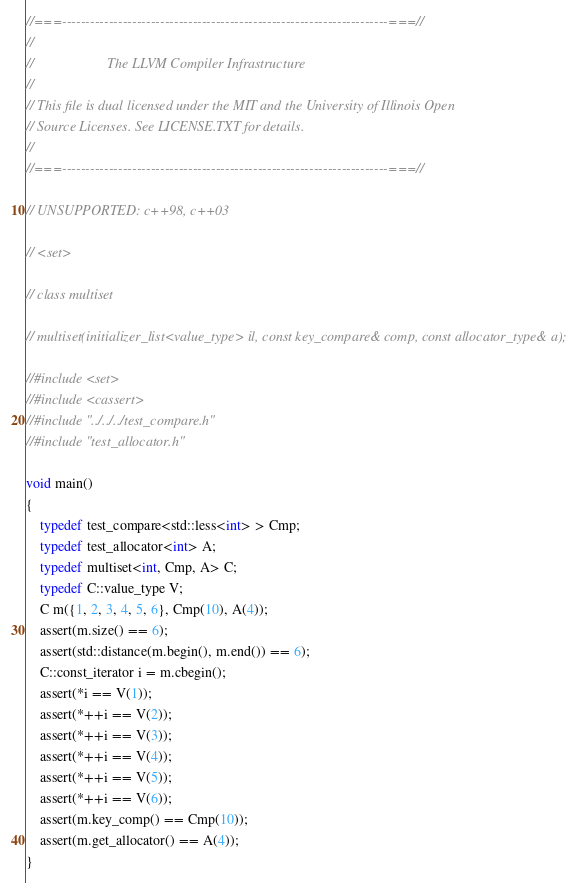Convert code to text. <code><loc_0><loc_0><loc_500><loc_500><_C++_>//===----------------------------------------------------------------------===//
//
//                     The LLVM Compiler Infrastructure
//
// This file is dual licensed under the MIT and the University of Illinois Open
// Source Licenses. See LICENSE.TXT for details.
//
//===----------------------------------------------------------------------===//

// UNSUPPORTED: c++98, c++03

// <set>

// class multiset

// multiset(initializer_list<value_type> il, const key_compare& comp, const allocator_type& a);

//#include <set>
//#include <cassert>
//#include "../../../test_compare.h"
//#include "test_allocator.h"

void main()
{
    typedef test_compare<std::less<int> > Cmp;
    typedef test_allocator<int> A;
    typedef multiset<int, Cmp, A> C;
    typedef C::value_type V;
    C m({1, 2, 3, 4, 5, 6}, Cmp(10), A(4));
    assert(m.size() == 6);
    assert(std::distance(m.begin(), m.end()) == 6);
    C::const_iterator i = m.cbegin();
    assert(*i == V(1));
    assert(*++i == V(2));
    assert(*++i == V(3));
    assert(*++i == V(4));
    assert(*++i == V(5));
    assert(*++i == V(6));
    assert(m.key_comp() == Cmp(10));
    assert(m.get_allocator() == A(4));
}
</code> 